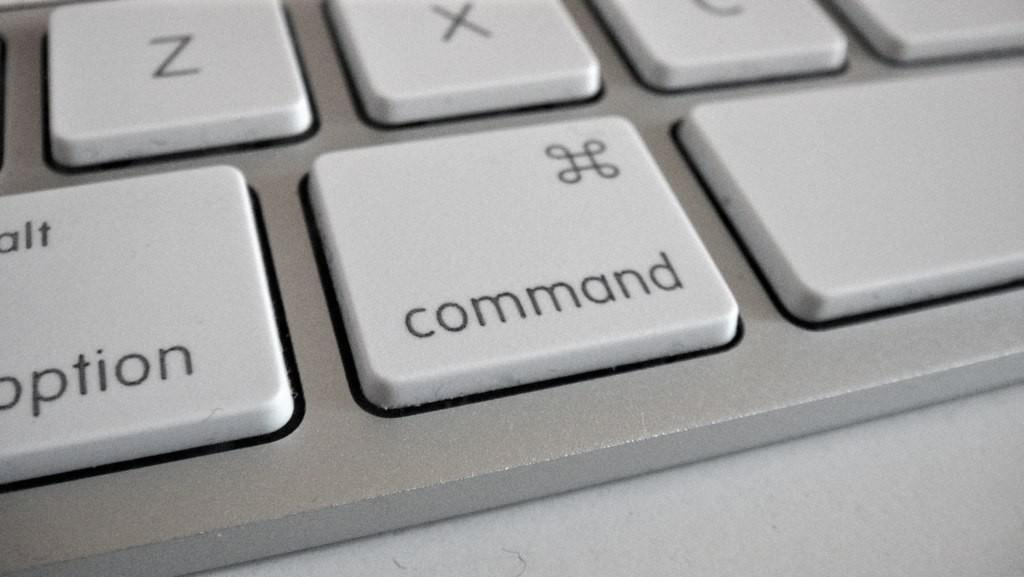What can be seen on the keyboard in the image? There are keys on a keyboard in the image. What type of list is visible on the keyboard in the image? There is no list present on the keyboard in the image; it only contains keys. 